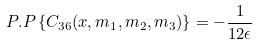Convert formula to latex. <formula><loc_0><loc_0><loc_500><loc_500>P . P \left \{ C _ { 3 6 } ( x , m _ { 1 } , m _ { 2 } , m _ { 3 } ) \right \} = - \frac { 1 } { 1 2 \epsilon }</formula> 